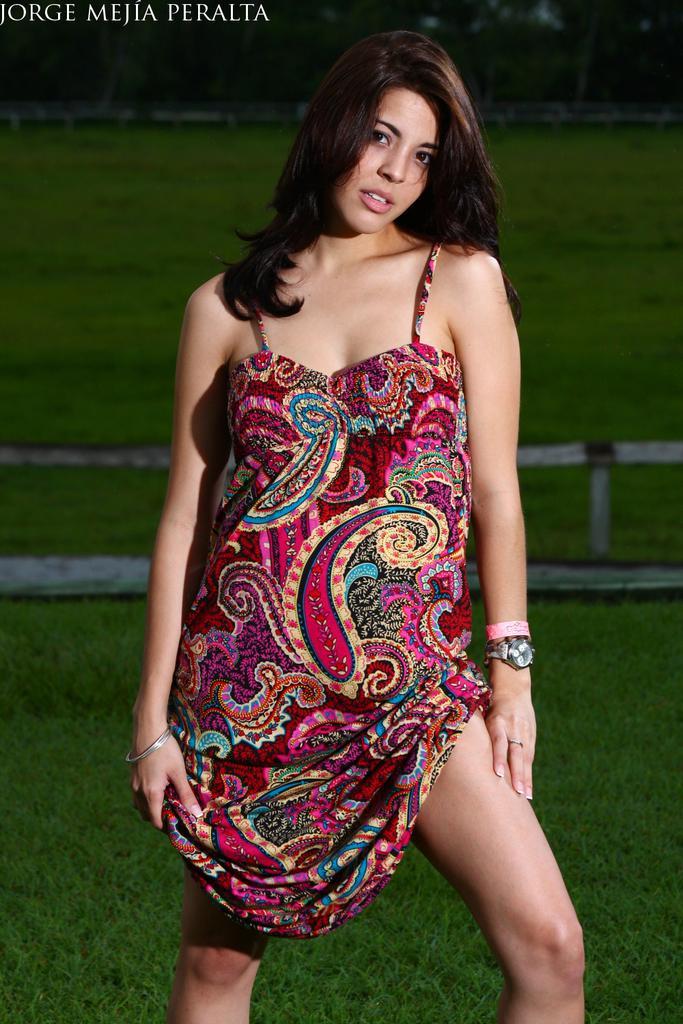In one or two sentences, can you explain what this image depicts? In this image there is a woman standing. Behind her there's grass on the ground. At the top there are trees. In the top left there is text on the image. 